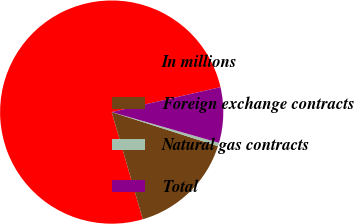<chart> <loc_0><loc_0><loc_500><loc_500><pie_chart><fcel>In millions<fcel>Foreign exchange contracts<fcel>Natural gas contracts<fcel>Total<nl><fcel>75.9%<fcel>15.57%<fcel>0.49%<fcel>8.03%<nl></chart> 